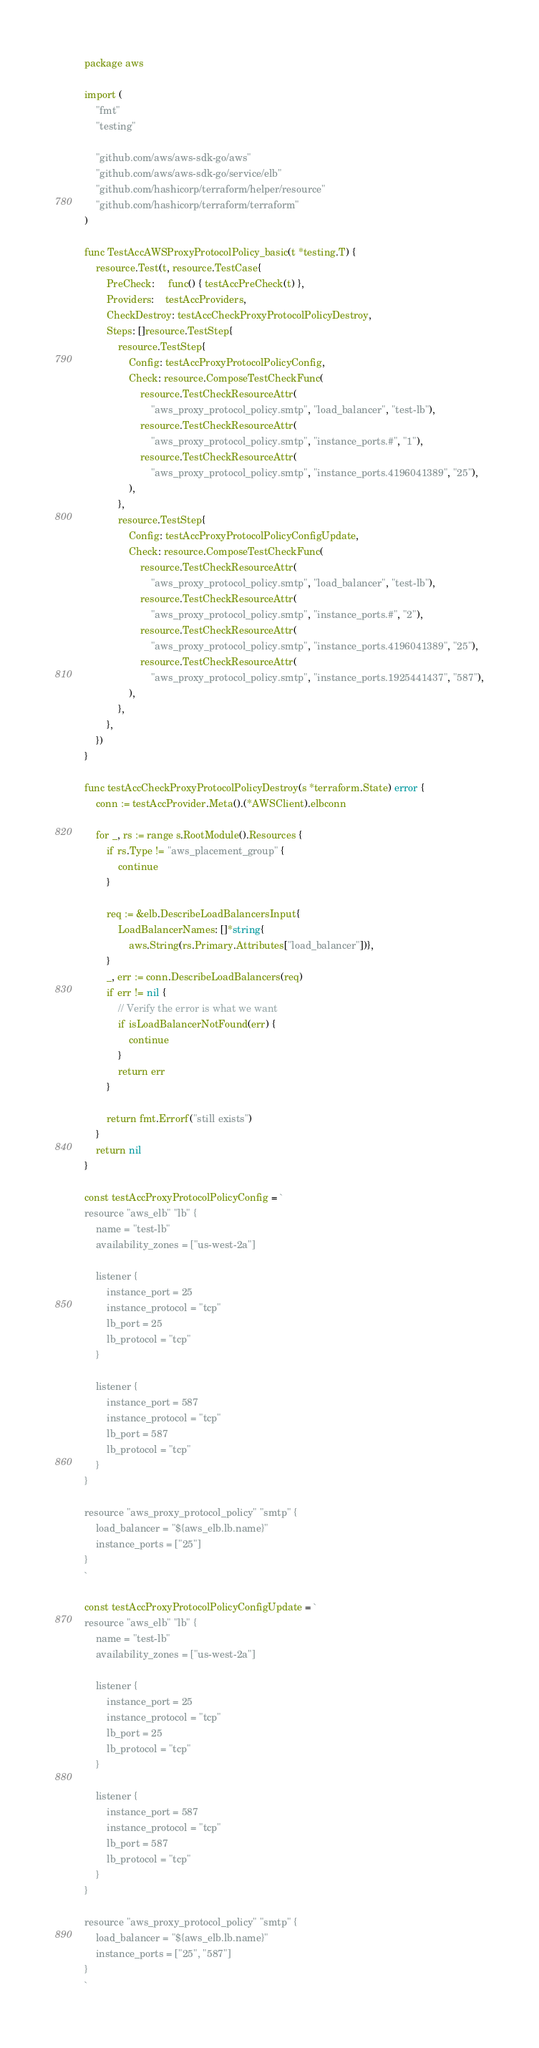Convert code to text. <code><loc_0><loc_0><loc_500><loc_500><_Go_>package aws

import (
	"fmt"
	"testing"

	"github.com/aws/aws-sdk-go/aws"
	"github.com/aws/aws-sdk-go/service/elb"
	"github.com/hashicorp/terraform/helper/resource"
	"github.com/hashicorp/terraform/terraform"
)

func TestAccAWSProxyProtocolPolicy_basic(t *testing.T) {
	resource.Test(t, resource.TestCase{
		PreCheck:     func() { testAccPreCheck(t) },
		Providers:    testAccProviders,
		CheckDestroy: testAccCheckProxyProtocolPolicyDestroy,
		Steps: []resource.TestStep{
			resource.TestStep{
				Config: testAccProxyProtocolPolicyConfig,
				Check: resource.ComposeTestCheckFunc(
					resource.TestCheckResourceAttr(
						"aws_proxy_protocol_policy.smtp", "load_balancer", "test-lb"),
					resource.TestCheckResourceAttr(
						"aws_proxy_protocol_policy.smtp", "instance_ports.#", "1"),
					resource.TestCheckResourceAttr(
						"aws_proxy_protocol_policy.smtp", "instance_ports.4196041389", "25"),
				),
			},
			resource.TestStep{
				Config: testAccProxyProtocolPolicyConfigUpdate,
				Check: resource.ComposeTestCheckFunc(
					resource.TestCheckResourceAttr(
						"aws_proxy_protocol_policy.smtp", "load_balancer", "test-lb"),
					resource.TestCheckResourceAttr(
						"aws_proxy_protocol_policy.smtp", "instance_ports.#", "2"),
					resource.TestCheckResourceAttr(
						"aws_proxy_protocol_policy.smtp", "instance_ports.4196041389", "25"),
					resource.TestCheckResourceAttr(
						"aws_proxy_protocol_policy.smtp", "instance_ports.1925441437", "587"),
				),
			},
		},
	})
}

func testAccCheckProxyProtocolPolicyDestroy(s *terraform.State) error {
	conn := testAccProvider.Meta().(*AWSClient).elbconn

	for _, rs := range s.RootModule().Resources {
		if rs.Type != "aws_placement_group" {
			continue
		}

		req := &elb.DescribeLoadBalancersInput{
			LoadBalancerNames: []*string{
				aws.String(rs.Primary.Attributes["load_balancer"])},
		}
		_, err := conn.DescribeLoadBalancers(req)
		if err != nil {
			// Verify the error is what we want
			if isLoadBalancerNotFound(err) {
				continue
			}
			return err
		}

		return fmt.Errorf("still exists")
	}
	return nil
}

const testAccProxyProtocolPolicyConfig = `
resource "aws_elb" "lb" {
	name = "test-lb"
	availability_zones = ["us-west-2a"]

	listener {
		instance_port = 25
		instance_protocol = "tcp"
		lb_port = 25
		lb_protocol = "tcp"
	}

	listener {
		instance_port = 587
		instance_protocol = "tcp"
		lb_port = 587
		lb_protocol = "tcp"
	}
}

resource "aws_proxy_protocol_policy" "smtp" {
	load_balancer = "${aws_elb.lb.name}"
	instance_ports = ["25"]
}
`

const testAccProxyProtocolPolicyConfigUpdate = `
resource "aws_elb" "lb" {
	name = "test-lb"
	availability_zones = ["us-west-2a"]

	listener {
		instance_port = 25
		instance_protocol = "tcp"
		lb_port = 25
		lb_protocol = "tcp"
	}

	listener {
		instance_port = 587
		instance_protocol = "tcp"
		lb_port = 587
		lb_protocol = "tcp"
	}
}

resource "aws_proxy_protocol_policy" "smtp" {
	load_balancer = "${aws_elb.lb.name}"
	instance_ports = ["25", "587"]
}
`
</code> 